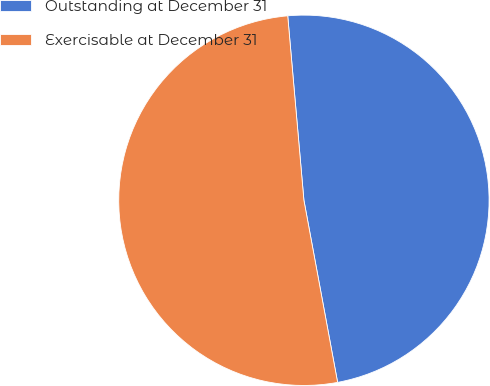<chart> <loc_0><loc_0><loc_500><loc_500><pie_chart><fcel>Outstanding at December 31<fcel>Exercisable at December 31<nl><fcel>48.48%<fcel>51.52%<nl></chart> 